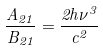<formula> <loc_0><loc_0><loc_500><loc_500>\frac { A _ { 2 1 } } { B _ { 2 1 } } = \frac { 2 h \nu ^ { 3 } } { c ^ { 2 } }</formula> 